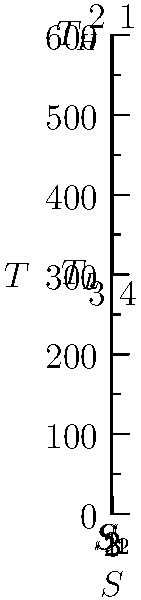Given the temperature-entropy (T-S) diagram for a heat engine operating between temperatures $T_H = 600K$ and $T_L = 300K$, calculate the thermal efficiency of the engine. Assume the engine follows the ideal Carnot cycle. To determine the efficiency of a Carnot heat engine using the given temperature-entropy diagram, we can follow these steps:

1. Recall the formula for the efficiency of a Carnot engine:
   $$\eta = 1 - \frac{T_L}{T_H}$$
   
   Where:
   $\eta$ is the efficiency
   $T_L$ is the lower temperature (cold reservoir)
   $T_H$ is the higher temperature (hot reservoir)

2. We are given:
   $T_H = 600K$
   $T_L = 300K$

3. Substitute these values into the formula:
   $$\eta = 1 - \frac{300K}{600K}$$

4. Simplify:
   $$\eta = 1 - \frac{1}{2} = \frac{1}{2} = 0.5$$

5. Convert to percentage:
   $$\eta = 0.5 \times 100\% = 50\%$$

Therefore, the thermal efficiency of the Carnot engine operating between 600K and 300K is 50%.
Answer: 50% 